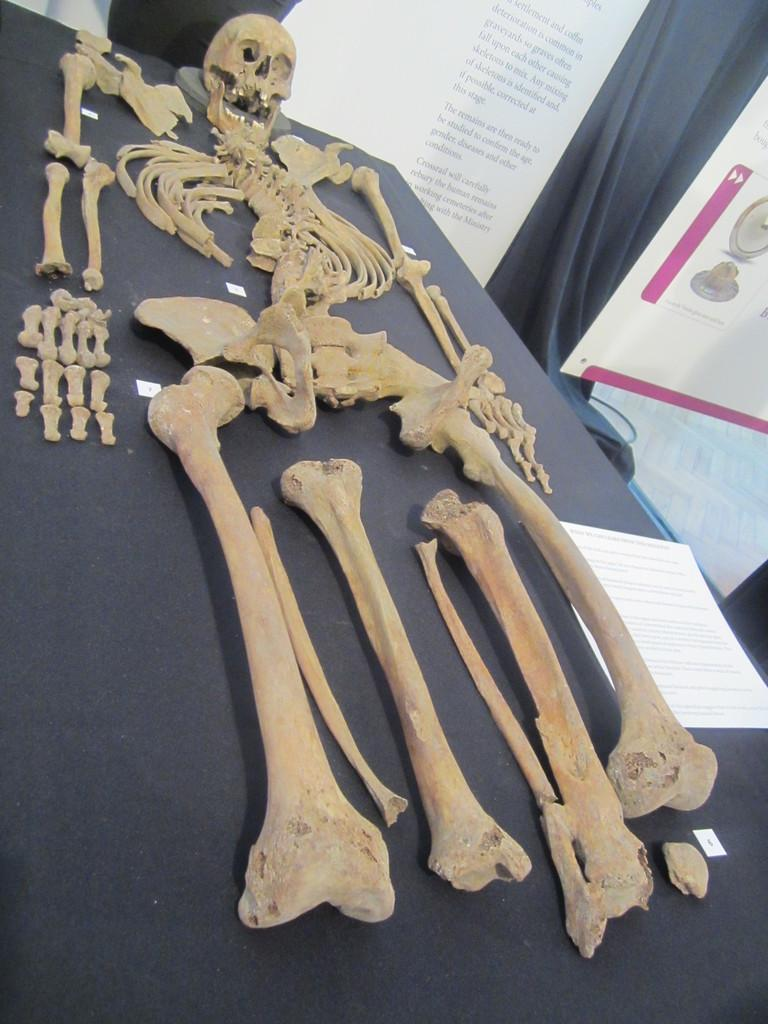What is the main subject of the image? There is a skeleton in the image. What can be seen in the image besides the skeleton? There are bones, a paper on a platform, and posters in the background of the image. What is the purpose of the platform in the image? The platform is likely used to display or hold the paper. What is present in the background of the image? There are posters and a curtain in the background of the image. How many eggs are visible in the image? There are no eggs present in the image. What type of snake can be seen slithering on the platform in the image? There is no snake present in the image; the platform holds a paper. 